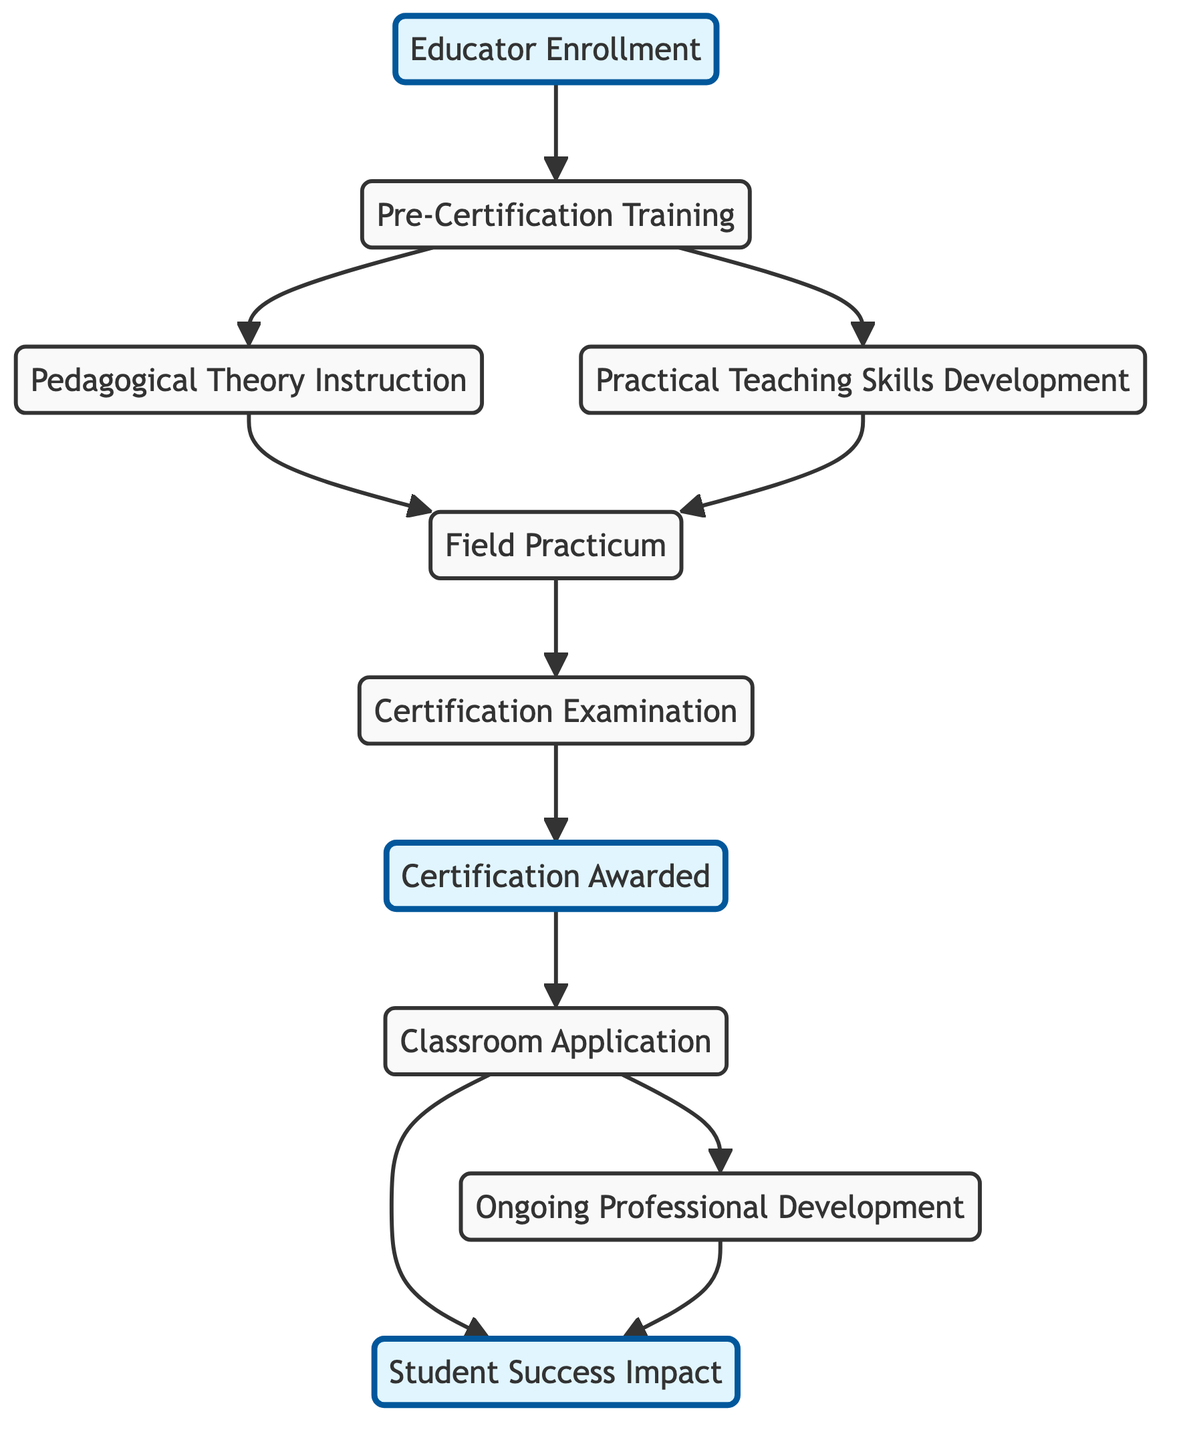What is the first node in the process? The first node is "Educator Enrollment," as it is the starting point of the flow in the diagram.
Answer: Educator Enrollment How many nodes are in the diagram? By counting each distinct labeled box in the diagram, we see there are ten nodes.
Answer: 10 What is the last step before "Certification Awarded"? The last step before "Certification Awarded" is "Certification Examination," which is directly connected to it in the flow.
Answer: Certification Examination What nodes lead to "Classroom Application"? The nodes that lead to "Classroom Application" are "Certification Awarded" and "Ongoing Professional Development," as indicated by the arrows directing towards it.
Answer: Certification Awarded, Ongoing Professional Development How many edges are there linking to "Student Success Impact"? There are two edges linking to "Student Success Impact," one from "Classroom Application" and another from "Ongoing Professional Development."
Answer: 2 Which node occurs after "Field Practicum"? The node that occurs after "Field Practicum" is "Certification Examination," as it is the next step in the diagram following "Field Practicum."
Answer: Certification Examination What is the relationship between "Pre-Certification Training" and "Practical Teaching Skills Development"? The relationship is that "Pre-Certification Training" leads to both "Pedagogical Theory Instruction" and "Practical Teaching Skills Development," indicating that they are parts of the training process occurring simultaneously.
Answer: Leads to Where does the process lead after "Ongoing Professional Development"? The process leads to "Student Success Impact" after "Ongoing Professional Development," as shown by the directed edge from one to the other.
Answer: Student Success Impact What is the significance of the highlighted nodes? The highlighted nodes represent key phases in the educator training and certification process, emphasizing important stages like enrollment, certification, and student success impact.
Answer: Key phases 